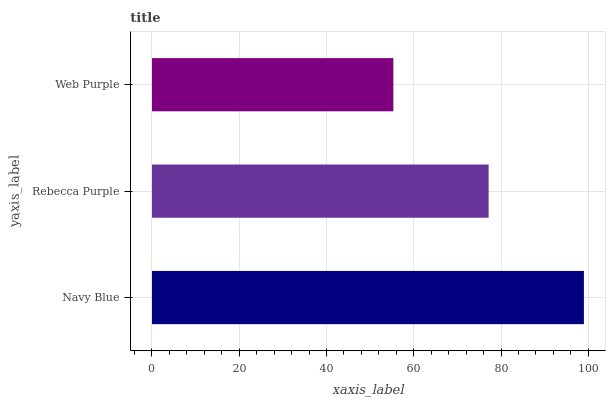Is Web Purple the minimum?
Answer yes or no. Yes. Is Navy Blue the maximum?
Answer yes or no. Yes. Is Rebecca Purple the minimum?
Answer yes or no. No. Is Rebecca Purple the maximum?
Answer yes or no. No. Is Navy Blue greater than Rebecca Purple?
Answer yes or no. Yes. Is Rebecca Purple less than Navy Blue?
Answer yes or no. Yes. Is Rebecca Purple greater than Navy Blue?
Answer yes or no. No. Is Navy Blue less than Rebecca Purple?
Answer yes or no. No. Is Rebecca Purple the high median?
Answer yes or no. Yes. Is Rebecca Purple the low median?
Answer yes or no. Yes. Is Web Purple the high median?
Answer yes or no. No. Is Navy Blue the low median?
Answer yes or no. No. 